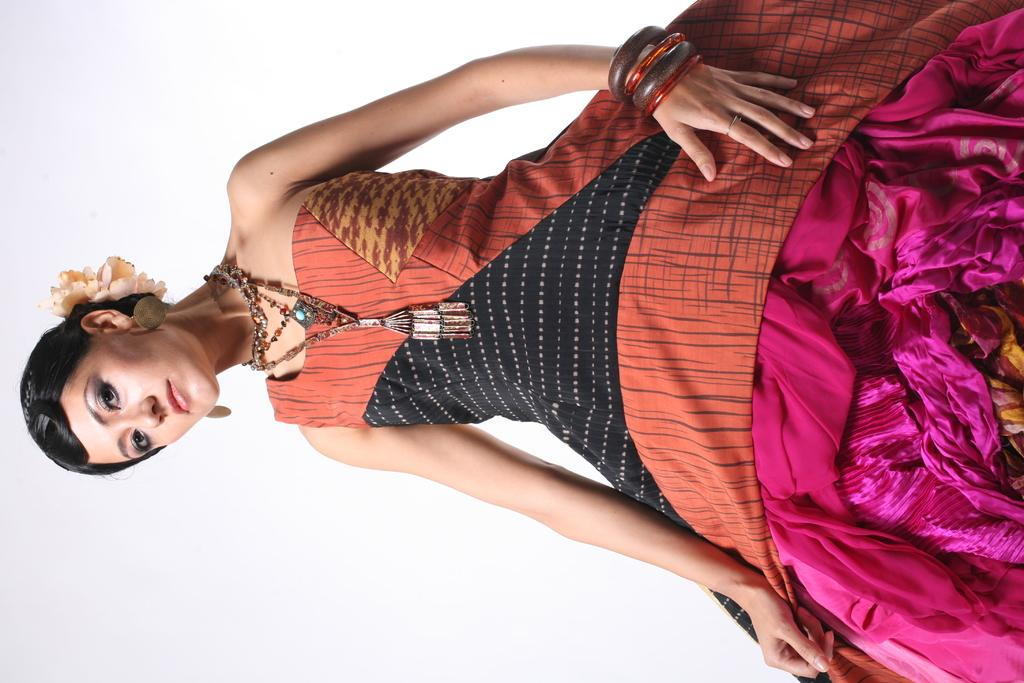What is the main subject of the image? There is a lady standing in the image. Can you describe the background of the image? There is a wall in the background of the image. What type of brass instrument is the lady playing in the image? There is no brass instrument present in the image; the lady is simply standing. 